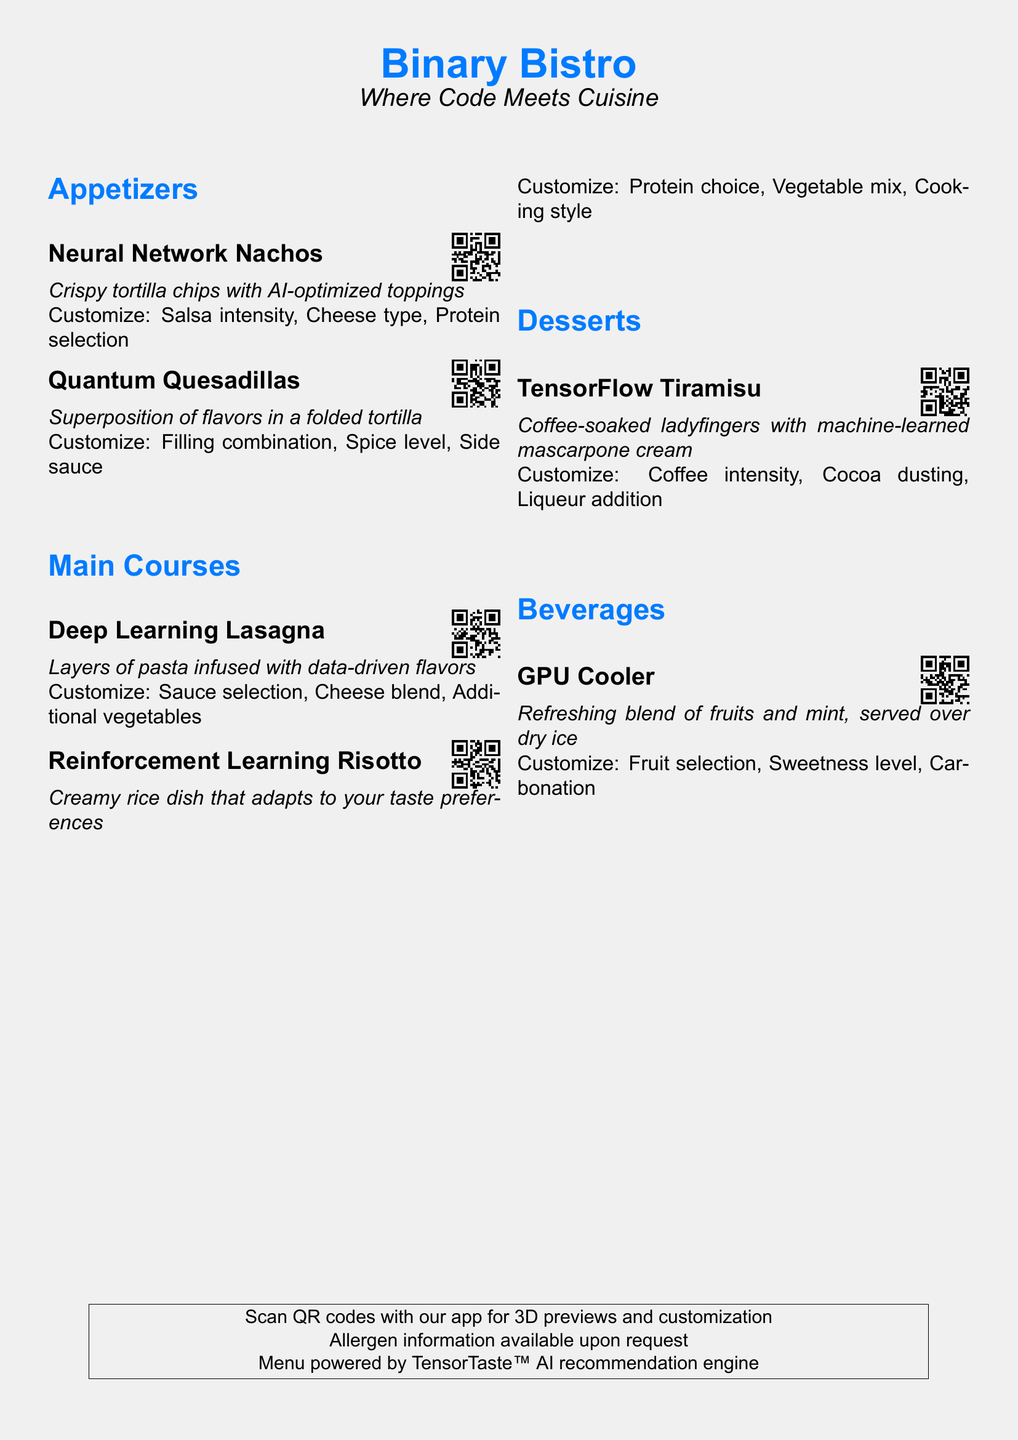What is the name of the restaurant? The restaurant is titled "Binary Bistro" in the center of the document.
Answer: Binary Bistro What is the slogan of the restaurant? The slogan is indicated below the restaurant name as "Where Code Meets Cuisine".
Answer: Where Code Meets Cuisine How many appetizers are listed on the menu? There are two appetizers detailed under the appetizers section.
Answer: 2 What type of dessert is offered? The dessert section includes "TensorFlow Tiramisu" indicating a specific dessert item.
Answer: TensorFlow Tiramisu What is one of the customization options for the GPU Cooler? The GPU Cooler has customization options listed, one of which is "Fruit selection".
Answer: Fruit selection What flavor aspect can be customized for the Neural Network Nachos? The nachos allow for "Salsa intensity" as a flavor customization option.
Answer: Salsa intensity What is the QR code used for in this menu? The QR codes are utilized for scanning to access 3D previews and customization options.
Answer: 3D previews and customization What is the main ingredient in the Deep Learning Lasagna? The lasagna is primarily described as having "Layers of pasta".
Answer: Layers of pasta How is the ambiance of the restaurant menu described visually? The entire page has a soft gray background that enhances the futuristic theme of the restaurant's offerings.
Answer: Soft gray background 